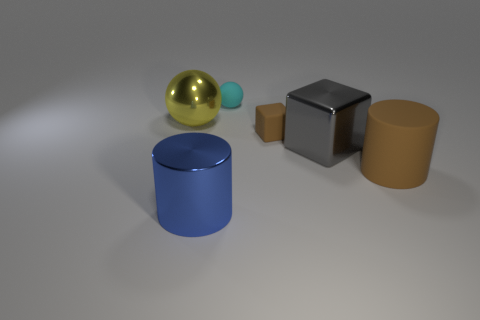Is the color of the thing on the right side of the large gray shiny object the same as the matte thing that is behind the big sphere?
Your answer should be compact. No. What is the shape of the shiny object that is in front of the big cylinder to the right of the cyan thing?
Make the answer very short. Cylinder. What number of other things are the same color as the large sphere?
Your answer should be compact. 0. Are the cylinder left of the brown cube and the brown object that is behind the big gray shiny block made of the same material?
Give a very brief answer. No. There is a ball that is on the right side of the large yellow object; what is its size?
Your response must be concise. Small. There is another object that is the same shape as the yellow object; what is it made of?
Offer a very short reply. Rubber. Is there any other thing that has the same size as the shiny cylinder?
Make the answer very short. Yes. There is a metal thing that is in front of the big rubber object; what is its shape?
Provide a short and direct response. Cylinder. What number of big gray metal things have the same shape as the big yellow object?
Provide a short and direct response. 0. Are there an equal number of cylinders behind the large gray object and cyan objects on the left side of the matte ball?
Provide a short and direct response. Yes. 